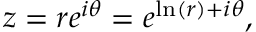Convert formula to latex. <formula><loc_0><loc_0><loc_500><loc_500>z = r e ^ { i \theta } = e ^ { \ln ( r ) + i \theta } ,</formula> 